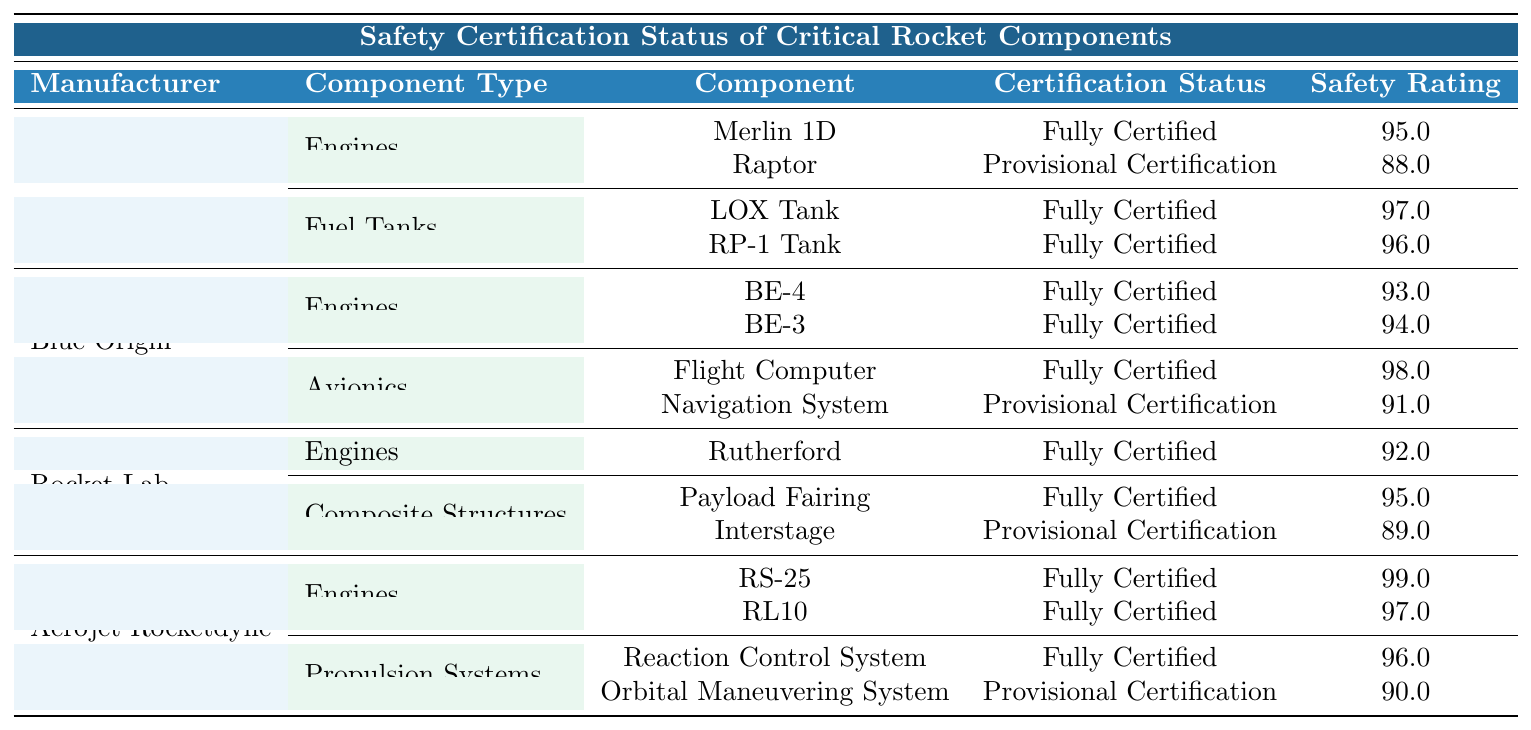What is the certification status of the Raptor engine from SpaceX? The table shows that the Raptor engine under the Engines category for SpaceX has a "Certification Status" of "Provisional Certification."
Answer: Provisional Certification Which component has the highest safety rating and what is that rating? By looking through the table, the RS-25 engine from Aerojet Rocketdyne has the highest "Safety Rating" of 99.
Answer: 99 How many components from Blue Origin are under provisional certification? In the Blue Origin section, there are two components listed: the Navigation System and the Raptor engine. Therefore, the count is 1.
Answer: 1 What are the last inspection dates for all fully certified components from Rocket Lab? The fully certified components from Rocket Lab are Rutherford, Payload Fairing, and the last inspection dates for these are 2023-02-18 and 2023-03-30, respectively.
Answer: 2023-02-18, 2023-03-30 Which manufacturer has the most fully certified engines? From the table, Aerojet Rocketdyne has 2 fully certified engines (RS-25 and RL10), while SpaceX and Blue Origin each have 2. However, Rocket Lab has only one fully certified engine. Aerojet Rocketdyne and Blue Origin are tied for the most fully certified engines.
Answer: Aerojet Rocketdyne and Blue Origin What is the average safety rating for the engines listed in the table? The safety ratings for engines are: Merlin 1D (95), Raptor (88), BE-4 (93), BE-3 (94), Rutherford (92), RS-25 (99), and RL10 (97). Summing these gives us 95 + 88 + 93 + 94 + 92 + 99 + 97 =  658. Since there are 7 engines, the average is 658/7 ≈ 94. Therefore, the average is approximately 94.
Answer: 94 Do any components from Aerojet Rocketdyne have a safety rating below 90? Checking the Aerojet Rocketdyne section, we see that the Orbital Maneuvering System has a safety rating of 90. Therefore, there are no components with a rating below 90.
Answer: No What is the last inspection date of the Navigation System from Blue Origin? The table specifies that the Navigation System has a last inspection date of 2023-04-22.
Answer: 2023-04-22 How does the safety rating of the Raptor compare to the safety rating of the LOX Tank? The Raptor has a safety rating of 88, while the LOX Tank's safety rating is 97. 97 is greater than 88, indicating LOX Tank has a higher safety rating compared to the Raptor.
Answer: LOX Tank has a higher rating than the Raptor 